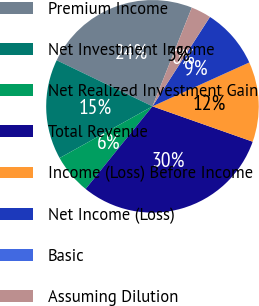Convert chart. <chart><loc_0><loc_0><loc_500><loc_500><pie_chart><fcel>Premium Income<fcel>Net Investment Income<fcel>Net Realized Investment Gain<fcel>Total Revenue<fcel>Income (Loss) Before Income<fcel>Net Income (Loss)<fcel>Basic<fcel>Assuming Dilution<nl><fcel>23.9%<fcel>15.22%<fcel>6.09%<fcel>30.42%<fcel>12.17%<fcel>9.13%<fcel>0.01%<fcel>3.05%<nl></chart> 